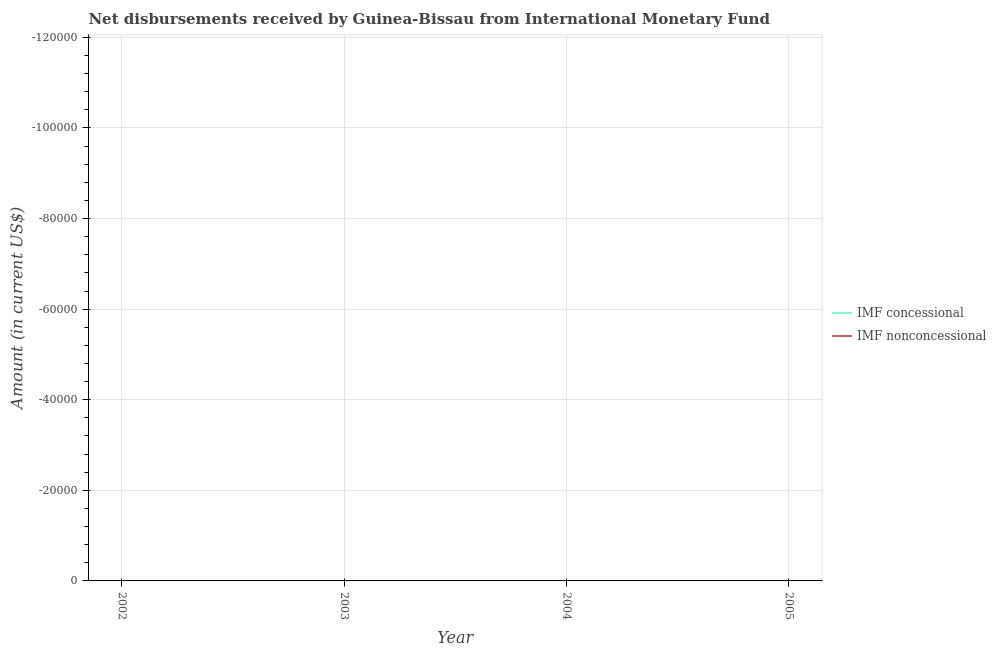How many different coloured lines are there?
Your response must be concise. 0. Is the number of lines equal to the number of legend labels?
Make the answer very short. No. What is the net concessional disbursements from imf in 2003?
Your response must be concise. 0. What is the total net concessional disbursements from imf in the graph?
Keep it short and to the point. 0. What is the difference between the net concessional disbursements from imf in 2005 and the net non concessional disbursements from imf in 2002?
Provide a short and direct response. 0. What is the average net non concessional disbursements from imf per year?
Ensure brevity in your answer.  0. In how many years, is the net non concessional disbursements from imf greater than -28000 US$?
Provide a succinct answer. 0. In how many years, is the net non concessional disbursements from imf greater than the average net non concessional disbursements from imf taken over all years?
Ensure brevity in your answer.  0. Does the net concessional disbursements from imf monotonically increase over the years?
Your response must be concise. No. Is the net concessional disbursements from imf strictly greater than the net non concessional disbursements from imf over the years?
Offer a terse response. No. Is the net concessional disbursements from imf strictly less than the net non concessional disbursements from imf over the years?
Ensure brevity in your answer.  Yes. How many years are there in the graph?
Give a very brief answer. 4. Does the graph contain grids?
Keep it short and to the point. Yes. How are the legend labels stacked?
Your response must be concise. Vertical. What is the title of the graph?
Make the answer very short. Net disbursements received by Guinea-Bissau from International Monetary Fund. What is the label or title of the Y-axis?
Make the answer very short. Amount (in current US$). What is the Amount (in current US$) in IMF nonconcessional in 2003?
Offer a terse response. 0. What is the Amount (in current US$) in IMF nonconcessional in 2004?
Your response must be concise. 0. What is the average Amount (in current US$) of IMF concessional per year?
Your answer should be compact. 0. What is the average Amount (in current US$) in IMF nonconcessional per year?
Make the answer very short. 0. 